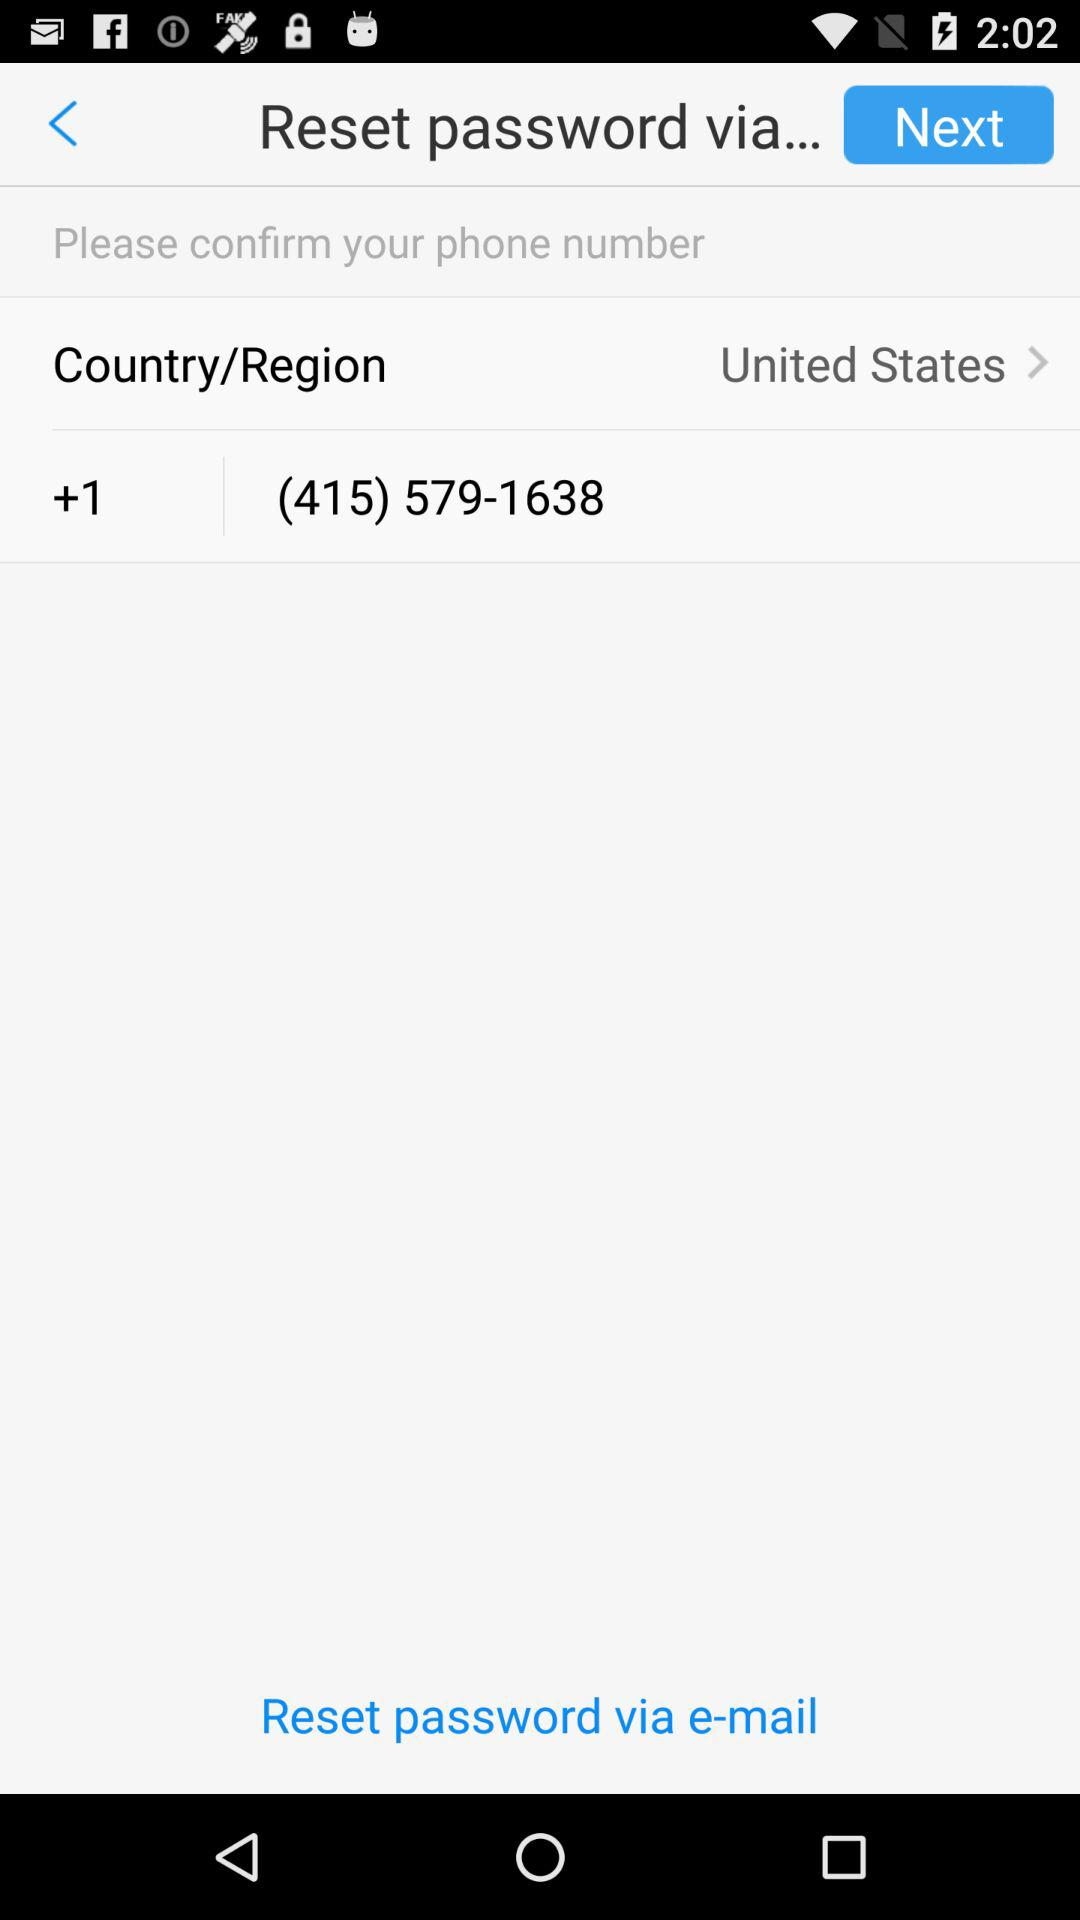What is the name of the country? The name of the country is the United States. 